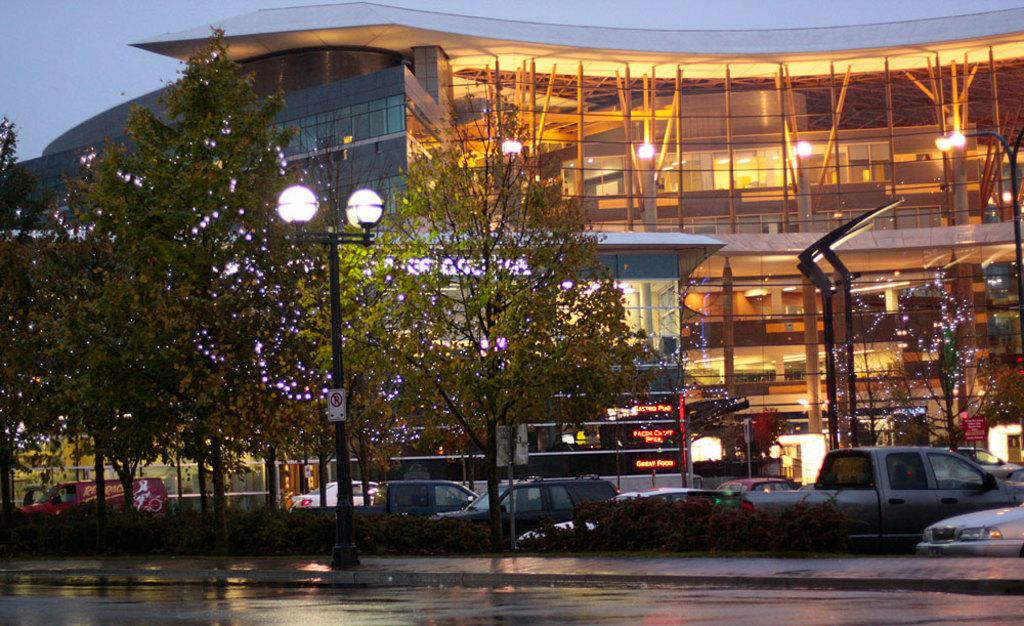What type of structures can be seen in the image? There are buildings in the image. What is happening in front of the buildings? There are vehicles moving on the road in front of the buildings. What type of vegetation is present in the image? There are trees in the image. What type of lighting is present along the road? There are street lights in the image. What can be seen in the background of the image? The sky is visible in the background of the image. How many arms are visible on the trees in the image? There are no arms visible on the trees in the image, as trees do not have arms. What type of fruit is hanging from the street lights in the image? There is no fruit hanging from the street lights in the image. 